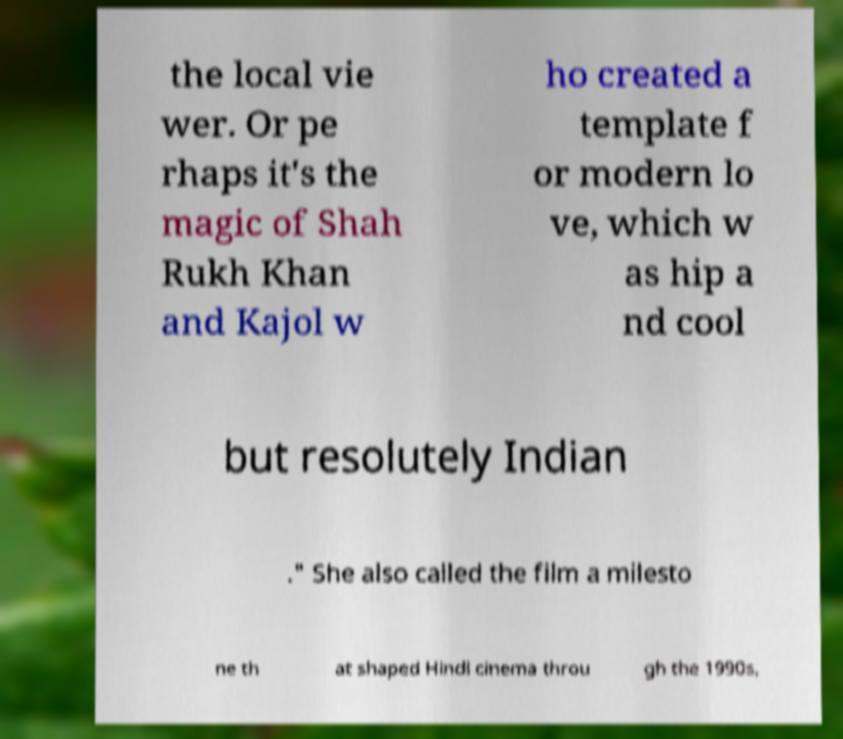For documentation purposes, I need the text within this image transcribed. Could you provide that? the local vie wer. Or pe rhaps it's the magic of Shah Rukh Khan and Kajol w ho created a template f or modern lo ve, which w as hip a nd cool but resolutely Indian ." She also called the film a milesto ne th at shaped Hindi cinema throu gh the 1990s, 